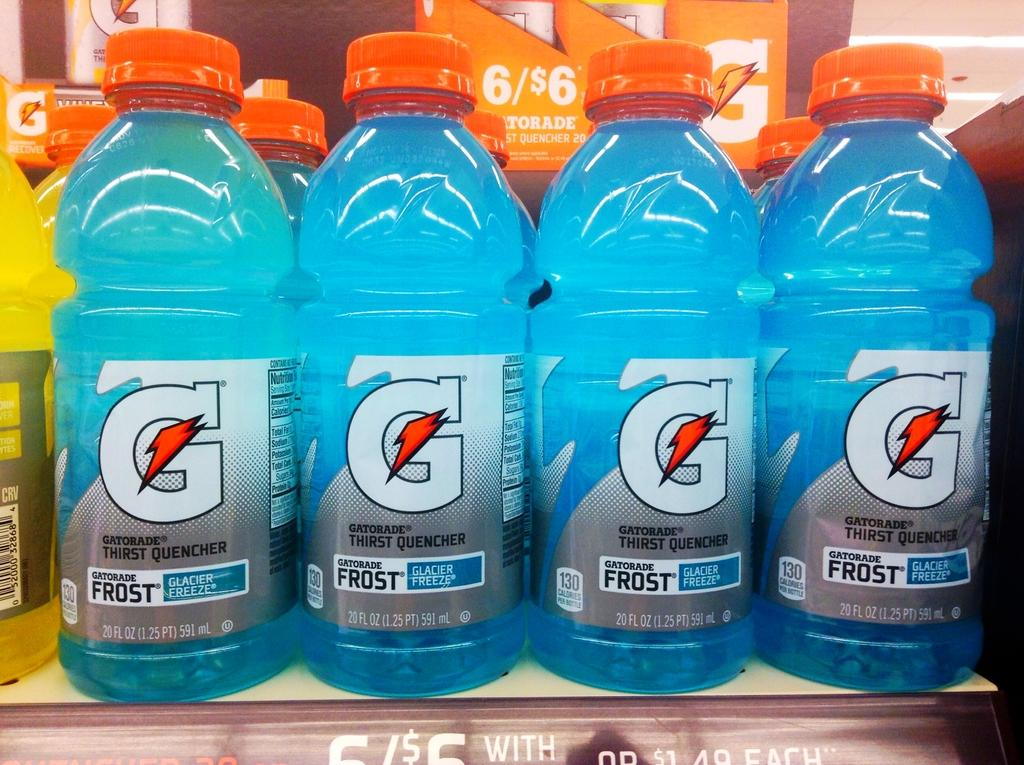What can be seen on the table in the image? There are many bottles on a table in the image. What can be observed about the bottles? The bottles have labels on them. Can you describe any specific details about the bottles? There is an orange cap on one of the bottles, and there is blue liquid inside one of the bottles. Are there any other colors of liquid visible in the image? Yes, there is yellow liquid inside one of the bottles. Can you see a crow perched on top of one of the bottles in the image? No, there is no crow present in the image. What type of boot is visible in the image? There is no boot present in the image. 